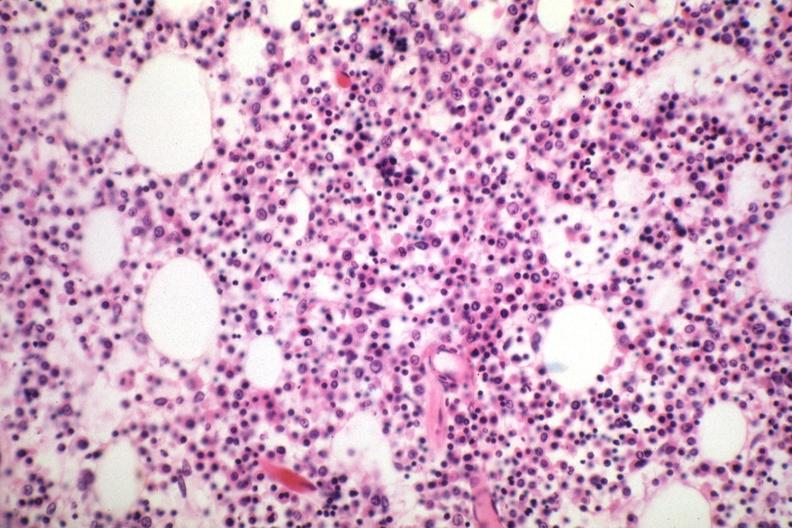s chronic myelogenous leukemia in blast crisis present?
Answer the question using a single word or phrase. No 